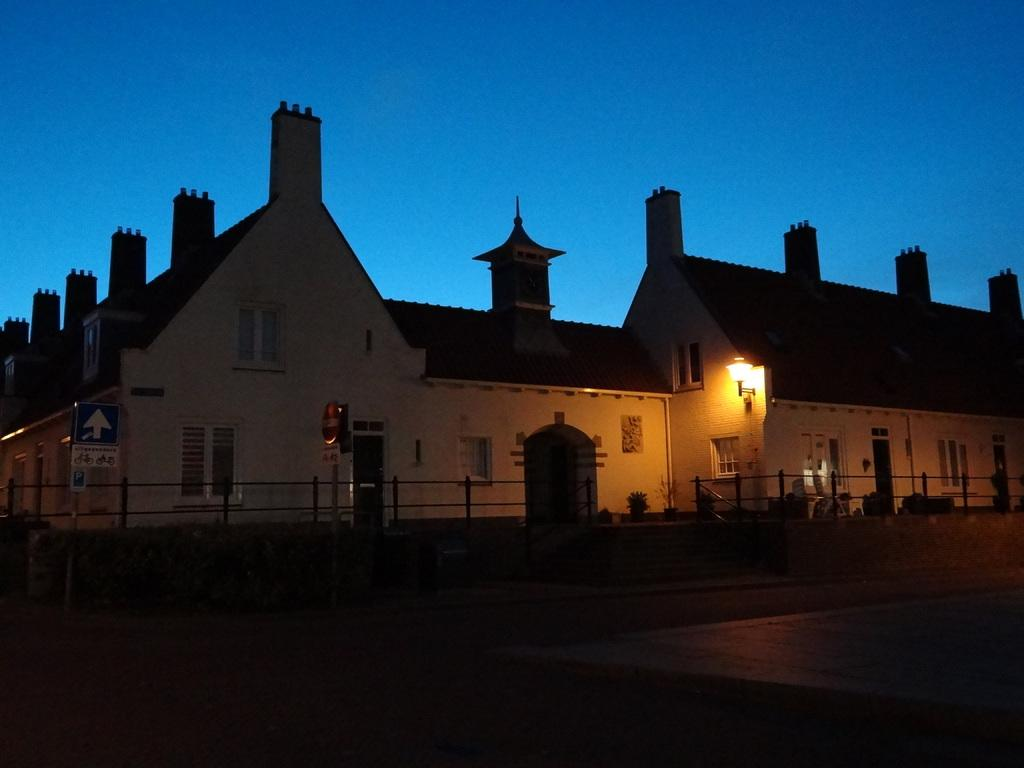What type of structures can be seen in the image? There are houses in the image. What features can be observed on the houses? There are windows and doors visible on the houses. What is the source of light in the image? Light is visible in the image. What type of vegetation is present in the image? There are plants in the image. What type of barrier can be seen in the image? There is a fence in the image. What material is present in the image? There are boards in the image. What can be seen in the background of the image? The sky is visible in the background of the image. What type of skate is being used by the person in the image? There is no person or skate present in the image. How many balloons are tied to the fence in the image? There are no balloons present in the image. 